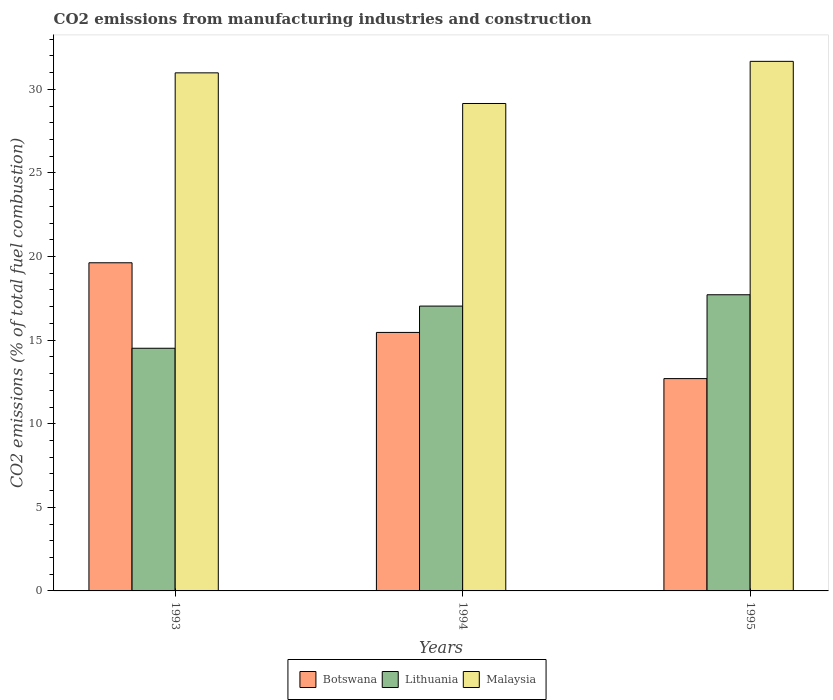How many groups of bars are there?
Keep it short and to the point. 3. Are the number of bars on each tick of the X-axis equal?
Offer a very short reply. Yes. How many bars are there on the 3rd tick from the left?
Your response must be concise. 3. In how many cases, is the number of bars for a given year not equal to the number of legend labels?
Ensure brevity in your answer.  0. What is the amount of CO2 emitted in Botswana in 1995?
Your response must be concise. 12.7. Across all years, what is the maximum amount of CO2 emitted in Malaysia?
Keep it short and to the point. 31.67. Across all years, what is the minimum amount of CO2 emitted in Botswana?
Provide a succinct answer. 12.7. What is the total amount of CO2 emitted in Lithuania in the graph?
Offer a terse response. 49.26. What is the difference between the amount of CO2 emitted in Malaysia in 1994 and that in 1995?
Make the answer very short. -2.52. What is the difference between the amount of CO2 emitted in Lithuania in 1993 and the amount of CO2 emitted in Botswana in 1995?
Provide a short and direct response. 1.82. What is the average amount of CO2 emitted in Botswana per year?
Your response must be concise. 15.93. In the year 1993, what is the difference between the amount of CO2 emitted in Malaysia and amount of CO2 emitted in Lithuania?
Your response must be concise. 16.47. In how many years, is the amount of CO2 emitted in Botswana greater than 18 %?
Provide a succinct answer. 1. What is the ratio of the amount of CO2 emitted in Malaysia in 1993 to that in 1994?
Keep it short and to the point. 1.06. Is the difference between the amount of CO2 emitted in Malaysia in 1993 and 1995 greater than the difference between the amount of CO2 emitted in Lithuania in 1993 and 1995?
Offer a terse response. Yes. What is the difference between the highest and the second highest amount of CO2 emitted in Lithuania?
Provide a succinct answer. 0.68. What is the difference between the highest and the lowest amount of CO2 emitted in Lithuania?
Ensure brevity in your answer.  3.2. In how many years, is the amount of CO2 emitted in Lithuania greater than the average amount of CO2 emitted in Lithuania taken over all years?
Ensure brevity in your answer.  2. Is the sum of the amount of CO2 emitted in Malaysia in 1993 and 1995 greater than the maximum amount of CO2 emitted in Botswana across all years?
Keep it short and to the point. Yes. What does the 3rd bar from the left in 1993 represents?
Provide a short and direct response. Malaysia. What does the 3rd bar from the right in 1994 represents?
Your response must be concise. Botswana. How many bars are there?
Offer a terse response. 9. Are all the bars in the graph horizontal?
Your response must be concise. No. How many years are there in the graph?
Your answer should be compact. 3. What is the difference between two consecutive major ticks on the Y-axis?
Make the answer very short. 5. Are the values on the major ticks of Y-axis written in scientific E-notation?
Offer a terse response. No. Does the graph contain grids?
Your answer should be very brief. No. Where does the legend appear in the graph?
Provide a succinct answer. Bottom center. How many legend labels are there?
Provide a succinct answer. 3. What is the title of the graph?
Your answer should be compact. CO2 emissions from manufacturing industries and construction. Does "Colombia" appear as one of the legend labels in the graph?
Give a very brief answer. No. What is the label or title of the X-axis?
Provide a short and direct response. Years. What is the label or title of the Y-axis?
Make the answer very short. CO2 emissions (% of total fuel combustion). What is the CO2 emissions (% of total fuel combustion) in Botswana in 1993?
Keep it short and to the point. 19.63. What is the CO2 emissions (% of total fuel combustion) of Lithuania in 1993?
Give a very brief answer. 14.51. What is the CO2 emissions (% of total fuel combustion) in Malaysia in 1993?
Give a very brief answer. 30.99. What is the CO2 emissions (% of total fuel combustion) in Botswana in 1994?
Your answer should be compact. 15.46. What is the CO2 emissions (% of total fuel combustion) of Lithuania in 1994?
Make the answer very short. 17.04. What is the CO2 emissions (% of total fuel combustion) in Malaysia in 1994?
Your answer should be compact. 29.15. What is the CO2 emissions (% of total fuel combustion) in Botswana in 1995?
Give a very brief answer. 12.7. What is the CO2 emissions (% of total fuel combustion) of Lithuania in 1995?
Make the answer very short. 17.71. What is the CO2 emissions (% of total fuel combustion) of Malaysia in 1995?
Provide a short and direct response. 31.67. Across all years, what is the maximum CO2 emissions (% of total fuel combustion) of Botswana?
Offer a terse response. 19.63. Across all years, what is the maximum CO2 emissions (% of total fuel combustion) in Lithuania?
Offer a very short reply. 17.71. Across all years, what is the maximum CO2 emissions (% of total fuel combustion) of Malaysia?
Offer a very short reply. 31.67. Across all years, what is the minimum CO2 emissions (% of total fuel combustion) of Botswana?
Offer a terse response. 12.7. Across all years, what is the minimum CO2 emissions (% of total fuel combustion) in Lithuania?
Provide a succinct answer. 14.51. Across all years, what is the minimum CO2 emissions (% of total fuel combustion) of Malaysia?
Your response must be concise. 29.15. What is the total CO2 emissions (% of total fuel combustion) in Botswana in the graph?
Provide a short and direct response. 47.79. What is the total CO2 emissions (% of total fuel combustion) of Lithuania in the graph?
Make the answer very short. 49.26. What is the total CO2 emissions (% of total fuel combustion) of Malaysia in the graph?
Give a very brief answer. 91.81. What is the difference between the CO2 emissions (% of total fuel combustion) in Botswana in 1993 and that in 1994?
Your answer should be compact. 4.17. What is the difference between the CO2 emissions (% of total fuel combustion) in Lithuania in 1993 and that in 1994?
Offer a terse response. -2.52. What is the difference between the CO2 emissions (% of total fuel combustion) in Malaysia in 1993 and that in 1994?
Your answer should be very brief. 1.83. What is the difference between the CO2 emissions (% of total fuel combustion) of Botswana in 1993 and that in 1995?
Your answer should be compact. 6.93. What is the difference between the CO2 emissions (% of total fuel combustion) of Lithuania in 1993 and that in 1995?
Your answer should be compact. -3.2. What is the difference between the CO2 emissions (% of total fuel combustion) of Malaysia in 1993 and that in 1995?
Provide a short and direct response. -0.69. What is the difference between the CO2 emissions (% of total fuel combustion) in Botswana in 1994 and that in 1995?
Provide a short and direct response. 2.76. What is the difference between the CO2 emissions (% of total fuel combustion) of Lithuania in 1994 and that in 1995?
Your response must be concise. -0.68. What is the difference between the CO2 emissions (% of total fuel combustion) of Malaysia in 1994 and that in 1995?
Your answer should be compact. -2.52. What is the difference between the CO2 emissions (% of total fuel combustion) in Botswana in 1993 and the CO2 emissions (% of total fuel combustion) in Lithuania in 1994?
Give a very brief answer. 2.59. What is the difference between the CO2 emissions (% of total fuel combustion) of Botswana in 1993 and the CO2 emissions (% of total fuel combustion) of Malaysia in 1994?
Your answer should be compact. -9.53. What is the difference between the CO2 emissions (% of total fuel combustion) in Lithuania in 1993 and the CO2 emissions (% of total fuel combustion) in Malaysia in 1994?
Ensure brevity in your answer.  -14.64. What is the difference between the CO2 emissions (% of total fuel combustion) in Botswana in 1993 and the CO2 emissions (% of total fuel combustion) in Lithuania in 1995?
Make the answer very short. 1.91. What is the difference between the CO2 emissions (% of total fuel combustion) of Botswana in 1993 and the CO2 emissions (% of total fuel combustion) of Malaysia in 1995?
Your answer should be very brief. -12.05. What is the difference between the CO2 emissions (% of total fuel combustion) in Lithuania in 1993 and the CO2 emissions (% of total fuel combustion) in Malaysia in 1995?
Give a very brief answer. -17.16. What is the difference between the CO2 emissions (% of total fuel combustion) of Botswana in 1994 and the CO2 emissions (% of total fuel combustion) of Lithuania in 1995?
Ensure brevity in your answer.  -2.25. What is the difference between the CO2 emissions (% of total fuel combustion) in Botswana in 1994 and the CO2 emissions (% of total fuel combustion) in Malaysia in 1995?
Make the answer very short. -16.21. What is the difference between the CO2 emissions (% of total fuel combustion) in Lithuania in 1994 and the CO2 emissions (% of total fuel combustion) in Malaysia in 1995?
Provide a short and direct response. -14.64. What is the average CO2 emissions (% of total fuel combustion) of Botswana per year?
Give a very brief answer. 15.93. What is the average CO2 emissions (% of total fuel combustion) in Lithuania per year?
Provide a short and direct response. 16.42. What is the average CO2 emissions (% of total fuel combustion) of Malaysia per year?
Your answer should be very brief. 30.6. In the year 1993, what is the difference between the CO2 emissions (% of total fuel combustion) in Botswana and CO2 emissions (% of total fuel combustion) in Lithuania?
Give a very brief answer. 5.11. In the year 1993, what is the difference between the CO2 emissions (% of total fuel combustion) of Botswana and CO2 emissions (% of total fuel combustion) of Malaysia?
Give a very brief answer. -11.36. In the year 1993, what is the difference between the CO2 emissions (% of total fuel combustion) in Lithuania and CO2 emissions (% of total fuel combustion) in Malaysia?
Offer a terse response. -16.47. In the year 1994, what is the difference between the CO2 emissions (% of total fuel combustion) in Botswana and CO2 emissions (% of total fuel combustion) in Lithuania?
Provide a succinct answer. -1.57. In the year 1994, what is the difference between the CO2 emissions (% of total fuel combustion) in Botswana and CO2 emissions (% of total fuel combustion) in Malaysia?
Make the answer very short. -13.69. In the year 1994, what is the difference between the CO2 emissions (% of total fuel combustion) of Lithuania and CO2 emissions (% of total fuel combustion) of Malaysia?
Provide a short and direct response. -12.12. In the year 1995, what is the difference between the CO2 emissions (% of total fuel combustion) of Botswana and CO2 emissions (% of total fuel combustion) of Lithuania?
Ensure brevity in your answer.  -5.02. In the year 1995, what is the difference between the CO2 emissions (% of total fuel combustion) in Botswana and CO2 emissions (% of total fuel combustion) in Malaysia?
Your response must be concise. -18.97. In the year 1995, what is the difference between the CO2 emissions (% of total fuel combustion) of Lithuania and CO2 emissions (% of total fuel combustion) of Malaysia?
Offer a very short reply. -13.96. What is the ratio of the CO2 emissions (% of total fuel combustion) in Botswana in 1993 to that in 1994?
Provide a succinct answer. 1.27. What is the ratio of the CO2 emissions (% of total fuel combustion) in Lithuania in 1993 to that in 1994?
Keep it short and to the point. 0.85. What is the ratio of the CO2 emissions (% of total fuel combustion) of Malaysia in 1993 to that in 1994?
Offer a very short reply. 1.06. What is the ratio of the CO2 emissions (% of total fuel combustion) of Botswana in 1993 to that in 1995?
Your response must be concise. 1.55. What is the ratio of the CO2 emissions (% of total fuel combustion) of Lithuania in 1993 to that in 1995?
Provide a short and direct response. 0.82. What is the ratio of the CO2 emissions (% of total fuel combustion) of Malaysia in 1993 to that in 1995?
Your response must be concise. 0.98. What is the ratio of the CO2 emissions (% of total fuel combustion) of Botswana in 1994 to that in 1995?
Your answer should be compact. 1.22. What is the ratio of the CO2 emissions (% of total fuel combustion) of Lithuania in 1994 to that in 1995?
Make the answer very short. 0.96. What is the ratio of the CO2 emissions (% of total fuel combustion) in Malaysia in 1994 to that in 1995?
Your response must be concise. 0.92. What is the difference between the highest and the second highest CO2 emissions (% of total fuel combustion) in Botswana?
Offer a terse response. 4.17. What is the difference between the highest and the second highest CO2 emissions (% of total fuel combustion) of Lithuania?
Give a very brief answer. 0.68. What is the difference between the highest and the second highest CO2 emissions (% of total fuel combustion) in Malaysia?
Your answer should be compact. 0.69. What is the difference between the highest and the lowest CO2 emissions (% of total fuel combustion) of Botswana?
Offer a terse response. 6.93. What is the difference between the highest and the lowest CO2 emissions (% of total fuel combustion) in Lithuania?
Offer a terse response. 3.2. What is the difference between the highest and the lowest CO2 emissions (% of total fuel combustion) in Malaysia?
Your response must be concise. 2.52. 